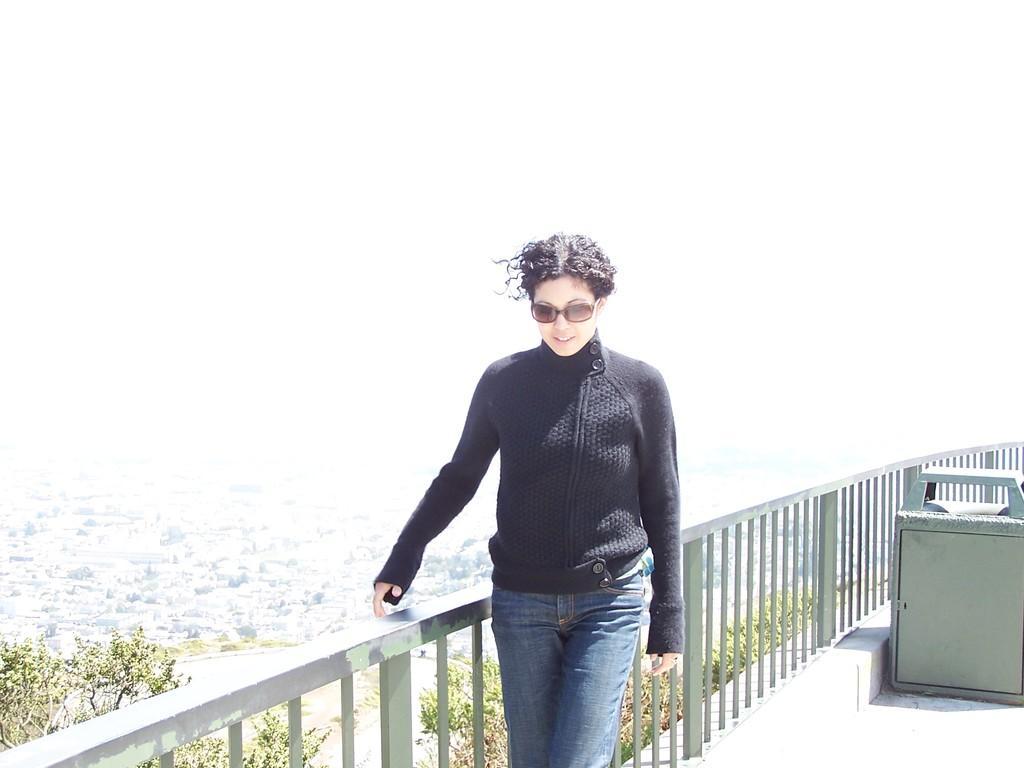In one or two sentences, can you explain what this image depicts? In this picture we can see a woman wearing a black T-shirt standing beside an iron railing. In the background, we can see trees. 